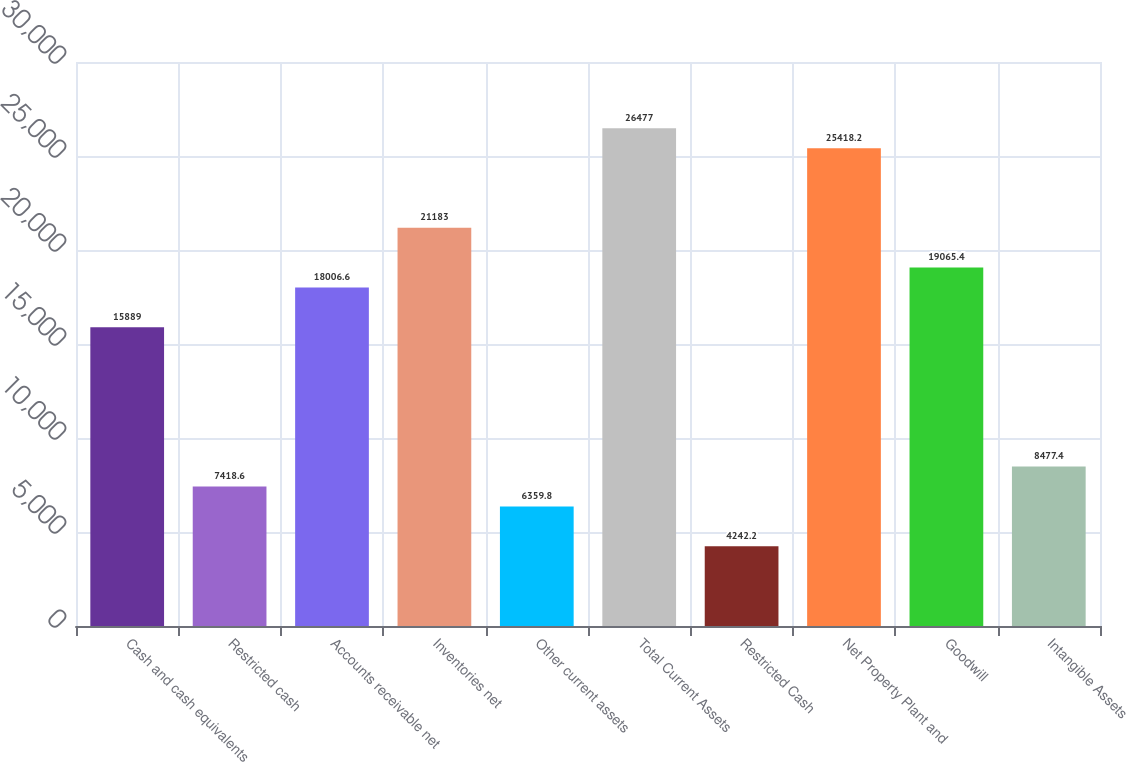<chart> <loc_0><loc_0><loc_500><loc_500><bar_chart><fcel>Cash and cash equivalents<fcel>Restricted cash<fcel>Accounts receivable net<fcel>Inventories net<fcel>Other current assets<fcel>Total Current Assets<fcel>Restricted Cash<fcel>Net Property Plant and<fcel>Goodwill<fcel>Intangible Assets<nl><fcel>15889<fcel>7418.6<fcel>18006.6<fcel>21183<fcel>6359.8<fcel>26477<fcel>4242.2<fcel>25418.2<fcel>19065.4<fcel>8477.4<nl></chart> 